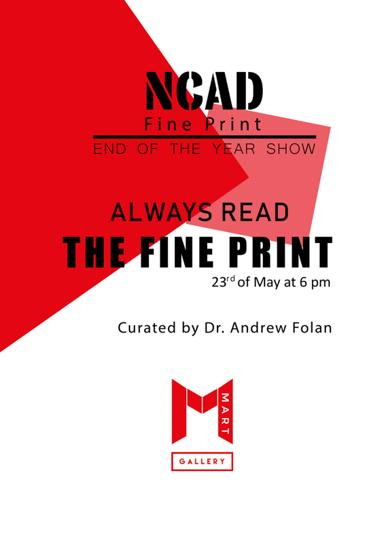What type of show is being advertised on the poster? This show is a showcase of fine print, possibly including detailed artworks, prints, and installations that emphasize the skill and creativity in print media. 